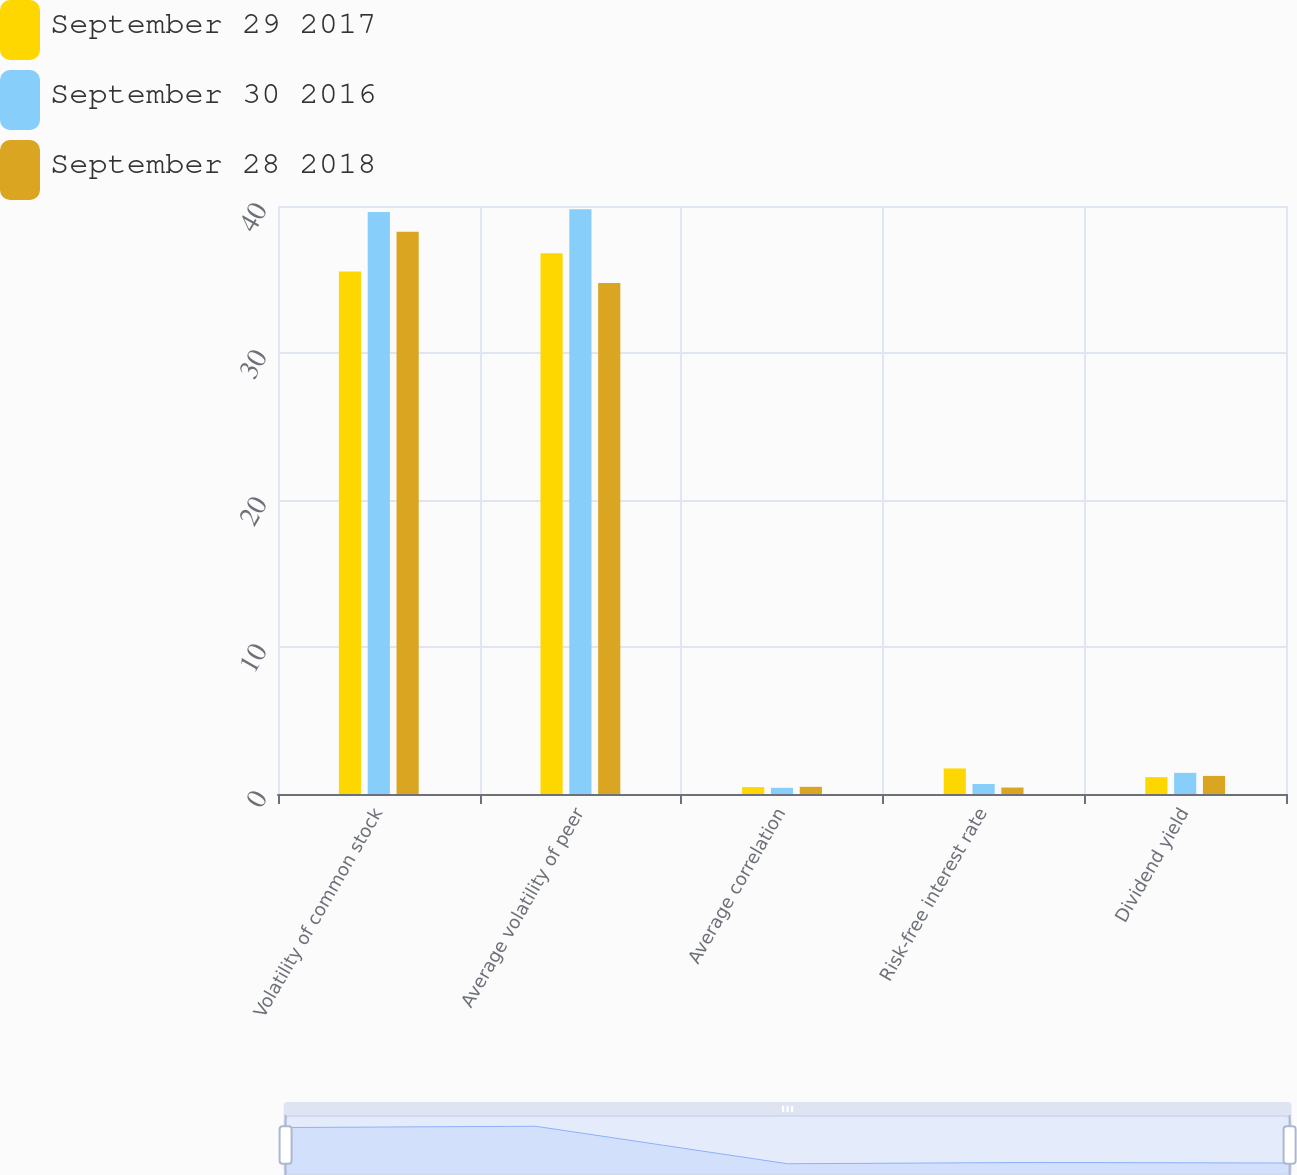Convert chart. <chart><loc_0><loc_0><loc_500><loc_500><stacked_bar_chart><ecel><fcel>Volatility of common stock<fcel>Average volatility of peer<fcel>Average correlation<fcel>Risk-free interest rate<fcel>Dividend yield<nl><fcel>September 29 2017<fcel>35.54<fcel>36.78<fcel>0.47<fcel>1.74<fcel>1.15<nl><fcel>September 30 2016<fcel>39.6<fcel>39.78<fcel>0.42<fcel>0.68<fcel>1.44<nl><fcel>September 28 2018<fcel>38.24<fcel>34.76<fcel>0.49<fcel>0.44<fcel>1.23<nl></chart> 